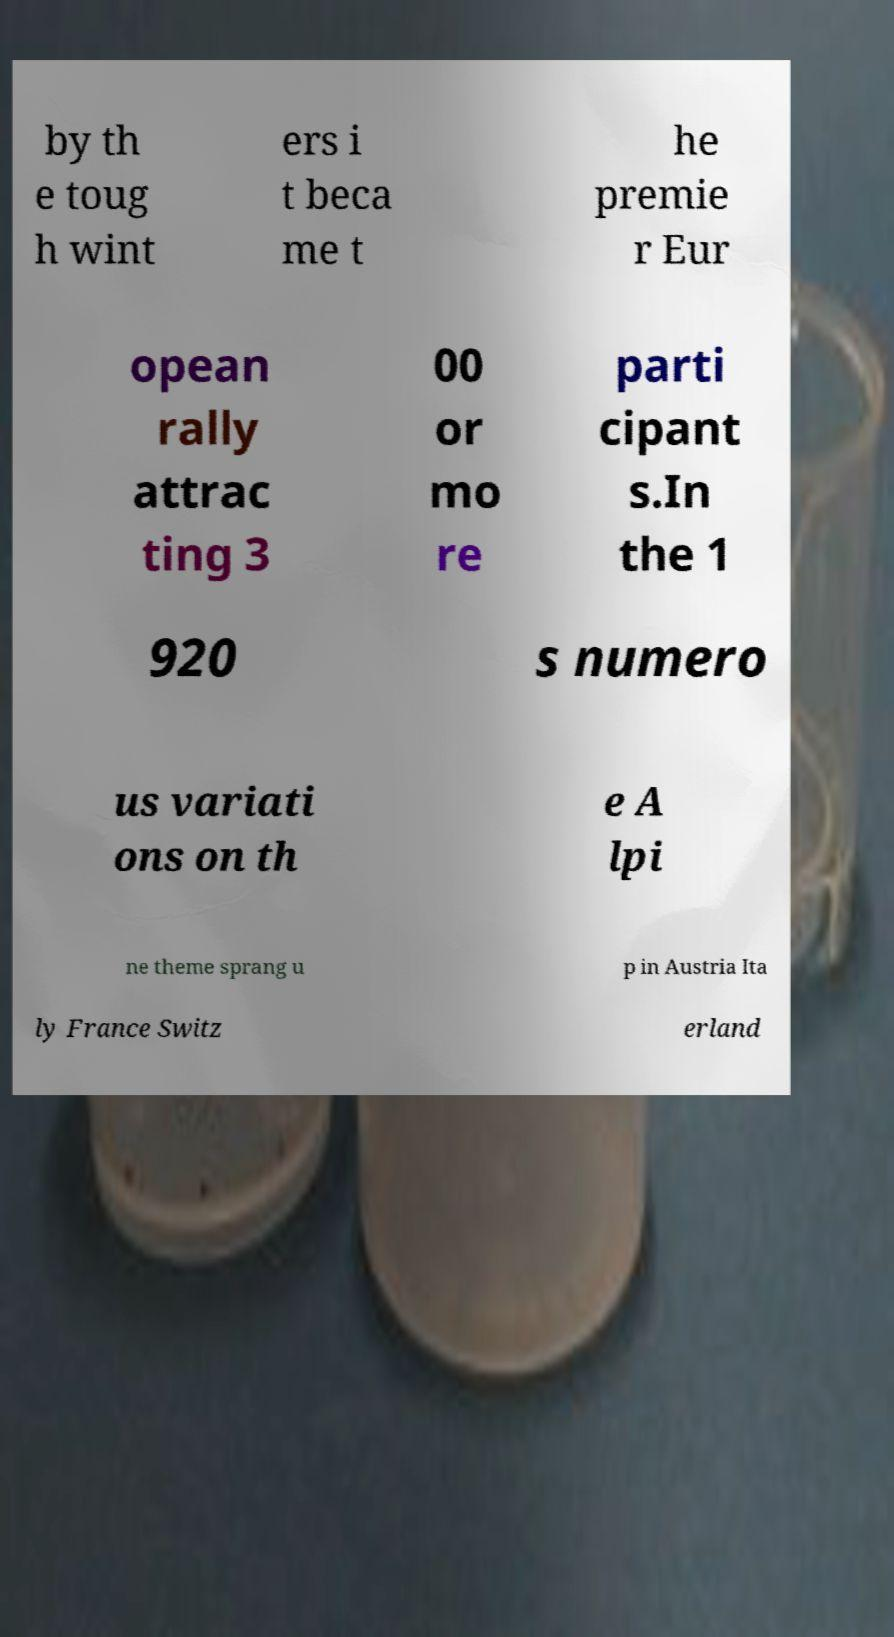Please read and relay the text visible in this image. What does it say? by th e toug h wint ers i t beca me t he premie r Eur opean rally attrac ting 3 00 or mo re parti cipant s.In the 1 920 s numero us variati ons on th e A lpi ne theme sprang u p in Austria Ita ly France Switz erland 